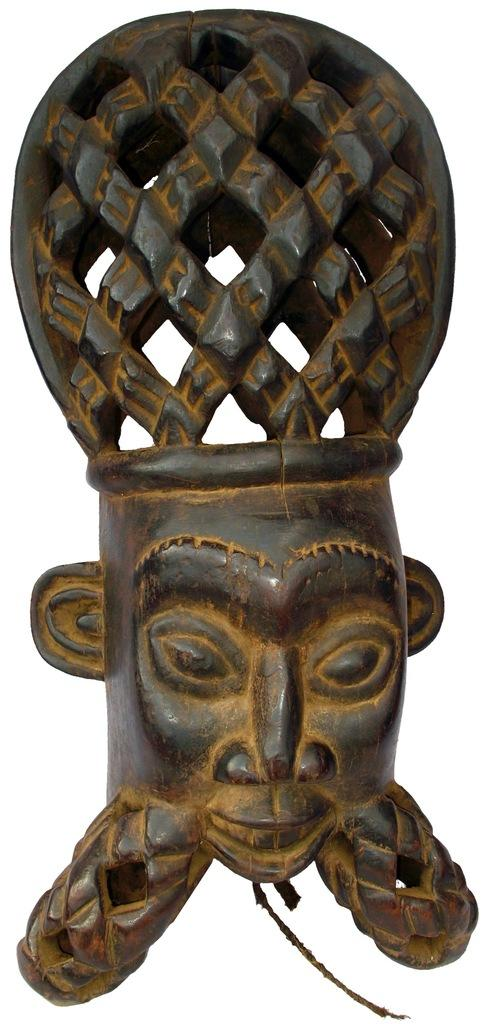What is the main subject of the image? There is a statue of a person in the image. What part of the statue is visible in the image? The statue's face is visible. What color is the background of the image? The background of the image is white. What type of dress is the statue wearing in the image? The statue is not wearing a dress, as it is a statue and not a living person. 